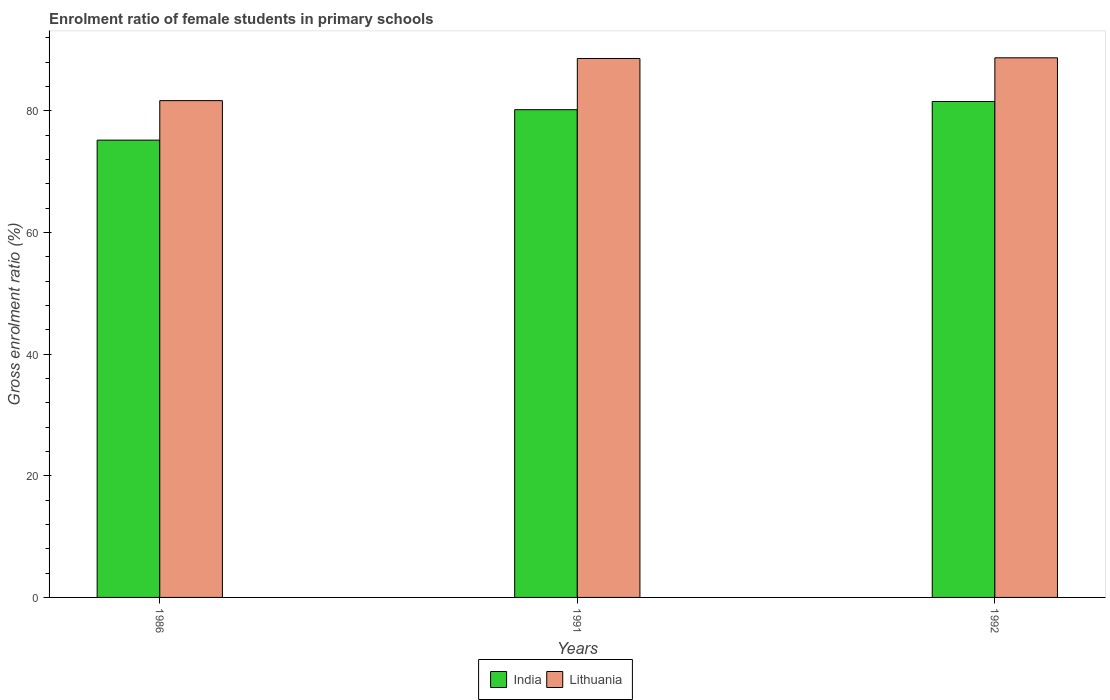How many groups of bars are there?
Keep it short and to the point. 3. Are the number of bars per tick equal to the number of legend labels?
Give a very brief answer. Yes. Are the number of bars on each tick of the X-axis equal?
Your response must be concise. Yes. How many bars are there on the 3rd tick from the left?
Provide a short and direct response. 2. What is the enrolment ratio of female students in primary schools in India in 1986?
Offer a very short reply. 75.18. Across all years, what is the maximum enrolment ratio of female students in primary schools in India?
Keep it short and to the point. 81.53. Across all years, what is the minimum enrolment ratio of female students in primary schools in India?
Make the answer very short. 75.18. In which year was the enrolment ratio of female students in primary schools in India maximum?
Ensure brevity in your answer.  1992. In which year was the enrolment ratio of female students in primary schools in India minimum?
Your answer should be compact. 1986. What is the total enrolment ratio of female students in primary schools in India in the graph?
Ensure brevity in your answer.  236.9. What is the difference between the enrolment ratio of female students in primary schools in Lithuania in 1986 and that in 1991?
Keep it short and to the point. -6.93. What is the difference between the enrolment ratio of female students in primary schools in India in 1986 and the enrolment ratio of female students in primary schools in Lithuania in 1992?
Your answer should be very brief. -13.54. What is the average enrolment ratio of female students in primary schools in India per year?
Offer a terse response. 78.97. In the year 1986, what is the difference between the enrolment ratio of female students in primary schools in India and enrolment ratio of female students in primary schools in Lithuania?
Your response must be concise. -6.49. What is the ratio of the enrolment ratio of female students in primary schools in Lithuania in 1991 to that in 1992?
Ensure brevity in your answer.  1. Is the enrolment ratio of female students in primary schools in Lithuania in 1986 less than that in 1991?
Offer a very short reply. Yes. What is the difference between the highest and the second highest enrolment ratio of female students in primary schools in Lithuania?
Offer a terse response. 0.11. What is the difference between the highest and the lowest enrolment ratio of female students in primary schools in Lithuania?
Keep it short and to the point. 7.04. In how many years, is the enrolment ratio of female students in primary schools in India greater than the average enrolment ratio of female students in primary schools in India taken over all years?
Ensure brevity in your answer.  2. Is the sum of the enrolment ratio of female students in primary schools in India in 1991 and 1992 greater than the maximum enrolment ratio of female students in primary schools in Lithuania across all years?
Ensure brevity in your answer.  Yes. What does the 1st bar from the left in 1986 represents?
Give a very brief answer. India. What does the 1st bar from the right in 1991 represents?
Give a very brief answer. Lithuania. How many bars are there?
Make the answer very short. 6. Are all the bars in the graph horizontal?
Your answer should be compact. No. How many years are there in the graph?
Your answer should be compact. 3. What is the difference between two consecutive major ticks on the Y-axis?
Provide a succinct answer. 20. Are the values on the major ticks of Y-axis written in scientific E-notation?
Provide a short and direct response. No. Where does the legend appear in the graph?
Provide a succinct answer. Bottom center. What is the title of the graph?
Keep it short and to the point. Enrolment ratio of female students in primary schools. Does "Latin America(developing only)" appear as one of the legend labels in the graph?
Offer a very short reply. No. What is the label or title of the Y-axis?
Offer a very short reply. Gross enrolment ratio (%). What is the Gross enrolment ratio (%) in India in 1986?
Make the answer very short. 75.18. What is the Gross enrolment ratio (%) of Lithuania in 1986?
Your answer should be compact. 81.67. What is the Gross enrolment ratio (%) of India in 1991?
Give a very brief answer. 80.18. What is the Gross enrolment ratio (%) of Lithuania in 1991?
Keep it short and to the point. 88.6. What is the Gross enrolment ratio (%) in India in 1992?
Offer a very short reply. 81.53. What is the Gross enrolment ratio (%) of Lithuania in 1992?
Keep it short and to the point. 88.71. Across all years, what is the maximum Gross enrolment ratio (%) of India?
Your answer should be very brief. 81.53. Across all years, what is the maximum Gross enrolment ratio (%) in Lithuania?
Offer a terse response. 88.71. Across all years, what is the minimum Gross enrolment ratio (%) in India?
Keep it short and to the point. 75.18. Across all years, what is the minimum Gross enrolment ratio (%) in Lithuania?
Provide a short and direct response. 81.67. What is the total Gross enrolment ratio (%) of India in the graph?
Your answer should be very brief. 236.9. What is the total Gross enrolment ratio (%) of Lithuania in the graph?
Your answer should be compact. 258.99. What is the difference between the Gross enrolment ratio (%) in India in 1986 and that in 1991?
Keep it short and to the point. -5. What is the difference between the Gross enrolment ratio (%) in Lithuania in 1986 and that in 1991?
Ensure brevity in your answer.  -6.93. What is the difference between the Gross enrolment ratio (%) of India in 1986 and that in 1992?
Keep it short and to the point. -6.35. What is the difference between the Gross enrolment ratio (%) in Lithuania in 1986 and that in 1992?
Give a very brief answer. -7.04. What is the difference between the Gross enrolment ratio (%) in India in 1991 and that in 1992?
Offer a very short reply. -1.35. What is the difference between the Gross enrolment ratio (%) of Lithuania in 1991 and that in 1992?
Offer a terse response. -0.11. What is the difference between the Gross enrolment ratio (%) in India in 1986 and the Gross enrolment ratio (%) in Lithuania in 1991?
Provide a succinct answer. -13.42. What is the difference between the Gross enrolment ratio (%) in India in 1986 and the Gross enrolment ratio (%) in Lithuania in 1992?
Make the answer very short. -13.54. What is the difference between the Gross enrolment ratio (%) in India in 1991 and the Gross enrolment ratio (%) in Lithuania in 1992?
Offer a very short reply. -8.53. What is the average Gross enrolment ratio (%) of India per year?
Offer a terse response. 78.97. What is the average Gross enrolment ratio (%) in Lithuania per year?
Make the answer very short. 86.33. In the year 1986, what is the difference between the Gross enrolment ratio (%) of India and Gross enrolment ratio (%) of Lithuania?
Offer a terse response. -6.49. In the year 1991, what is the difference between the Gross enrolment ratio (%) in India and Gross enrolment ratio (%) in Lithuania?
Your answer should be very brief. -8.42. In the year 1992, what is the difference between the Gross enrolment ratio (%) in India and Gross enrolment ratio (%) in Lithuania?
Your response must be concise. -7.18. What is the ratio of the Gross enrolment ratio (%) of India in 1986 to that in 1991?
Your answer should be very brief. 0.94. What is the ratio of the Gross enrolment ratio (%) of Lithuania in 1986 to that in 1991?
Keep it short and to the point. 0.92. What is the ratio of the Gross enrolment ratio (%) of India in 1986 to that in 1992?
Your answer should be very brief. 0.92. What is the ratio of the Gross enrolment ratio (%) of Lithuania in 1986 to that in 1992?
Provide a short and direct response. 0.92. What is the ratio of the Gross enrolment ratio (%) in India in 1991 to that in 1992?
Make the answer very short. 0.98. What is the difference between the highest and the second highest Gross enrolment ratio (%) in India?
Provide a short and direct response. 1.35. What is the difference between the highest and the second highest Gross enrolment ratio (%) of Lithuania?
Your answer should be compact. 0.11. What is the difference between the highest and the lowest Gross enrolment ratio (%) in India?
Make the answer very short. 6.35. What is the difference between the highest and the lowest Gross enrolment ratio (%) in Lithuania?
Keep it short and to the point. 7.04. 